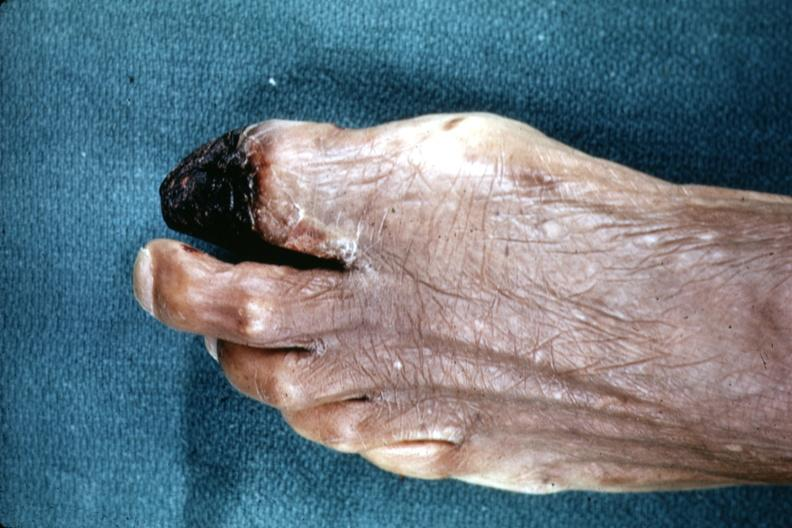does this image show excellent example of gangrene of great toe?
Answer the question using a single word or phrase. Yes 